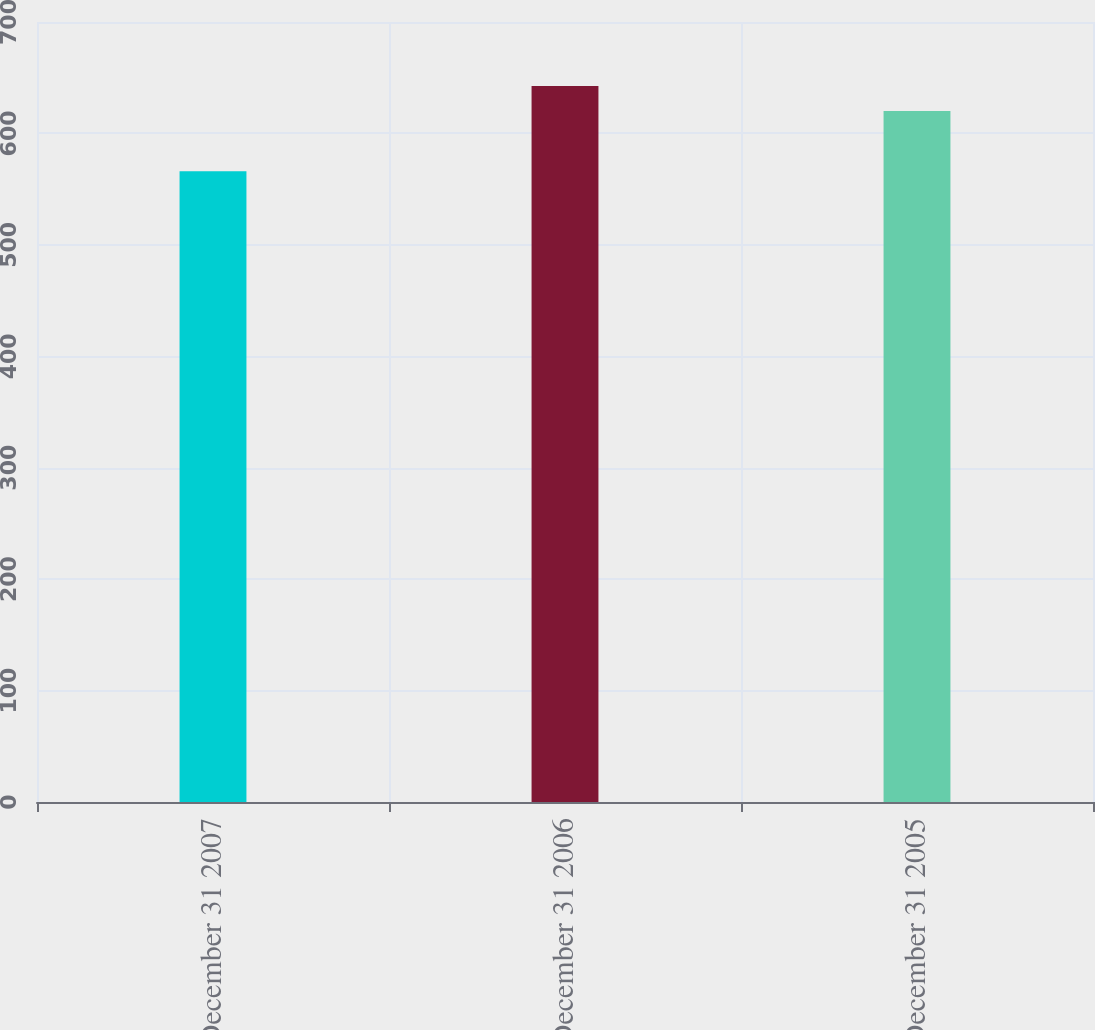Convert chart. <chart><loc_0><loc_0><loc_500><loc_500><bar_chart><fcel>December 31 2007<fcel>December 31 2006<fcel>December 31 2005<nl><fcel>566.1<fcel>642.5<fcel>620.1<nl></chart> 